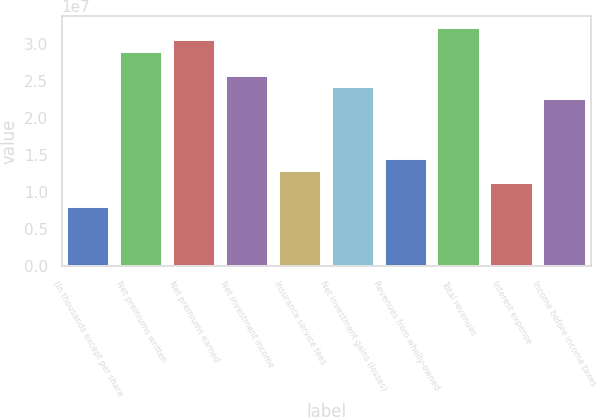Convert chart. <chart><loc_0><loc_0><loc_500><loc_500><bar_chart><fcel>(In thousands except per share<fcel>Net premiums written<fcel>Net premiums earned<fcel>Net investment income<fcel>Insurance service fees<fcel>Net investment gains (losses)<fcel>Revenues from wholly-owned<fcel>Total revenues<fcel>Interest expense<fcel>Income before income taxes<nl><fcel>8.03706e+06<fcel>2.89334e+07<fcel>3.05408e+07<fcel>2.57186e+07<fcel>1.28593e+07<fcel>2.41112e+07<fcel>1.44667e+07<fcel>3.21482e+07<fcel>1.12519e+07<fcel>2.25038e+07<nl></chart> 